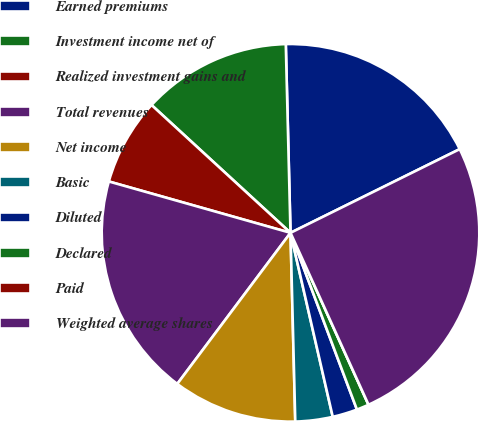Convert chart. <chart><loc_0><loc_0><loc_500><loc_500><pie_chart><fcel>Earned premiums<fcel>Investment income net of<fcel>Realized investment gains and<fcel>Total revenues<fcel>Net income<fcel>Basic<fcel>Diluted<fcel>Declared<fcel>Paid<fcel>Weighted average shares<nl><fcel>18.09%<fcel>12.77%<fcel>7.45%<fcel>19.15%<fcel>10.64%<fcel>3.19%<fcel>2.13%<fcel>1.06%<fcel>0.0%<fcel>25.53%<nl></chart> 